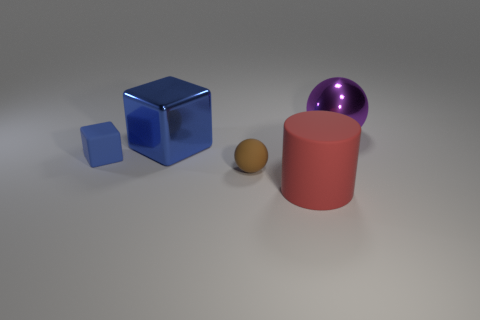Is the shape of the small brown object the same as the large purple object?
Provide a short and direct response. Yes. How many things are both behind the rubber ball and on the left side of the large red matte object?
Ensure brevity in your answer.  2. How many metal objects are either small blue objects or brown objects?
Give a very brief answer. 0. There is a blue block that is left of the blue shiny cube that is behind the brown ball; how big is it?
Your answer should be very brief. Small. There is another cube that is the same color as the shiny block; what is its material?
Ensure brevity in your answer.  Rubber. There is a rubber object on the right side of the tiny object in front of the tiny rubber block; is there a tiny blue matte thing in front of it?
Provide a short and direct response. No. Do the thing on the left side of the metal cube and the blue thing that is behind the small rubber block have the same material?
Your answer should be very brief. No. How many things are big green matte cylinders or large things behind the large cube?
Provide a succinct answer. 1. How many other small blue objects are the same shape as the blue metal thing?
Make the answer very short. 1. What material is the brown ball that is the same size as the rubber block?
Provide a short and direct response. Rubber. 